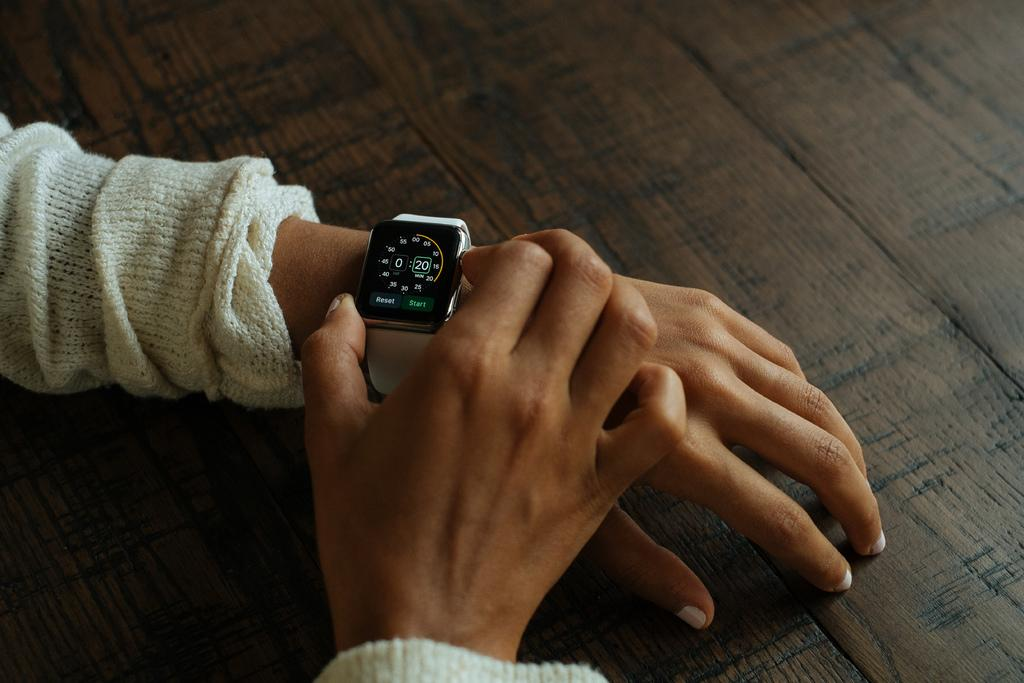<image>
Present a compact description of the photo's key features. A person in a white shirt is setting their smart watch for a 20 minute timer 